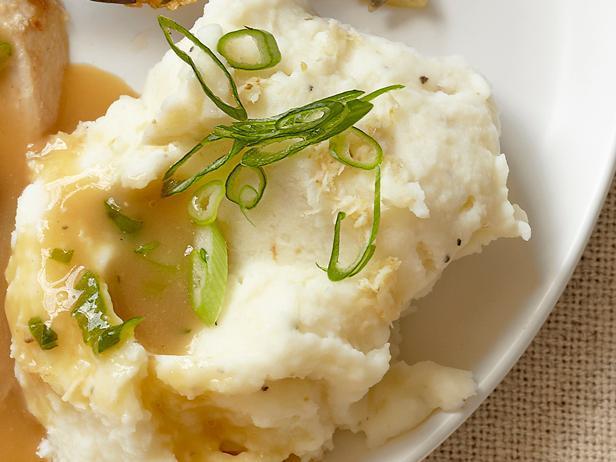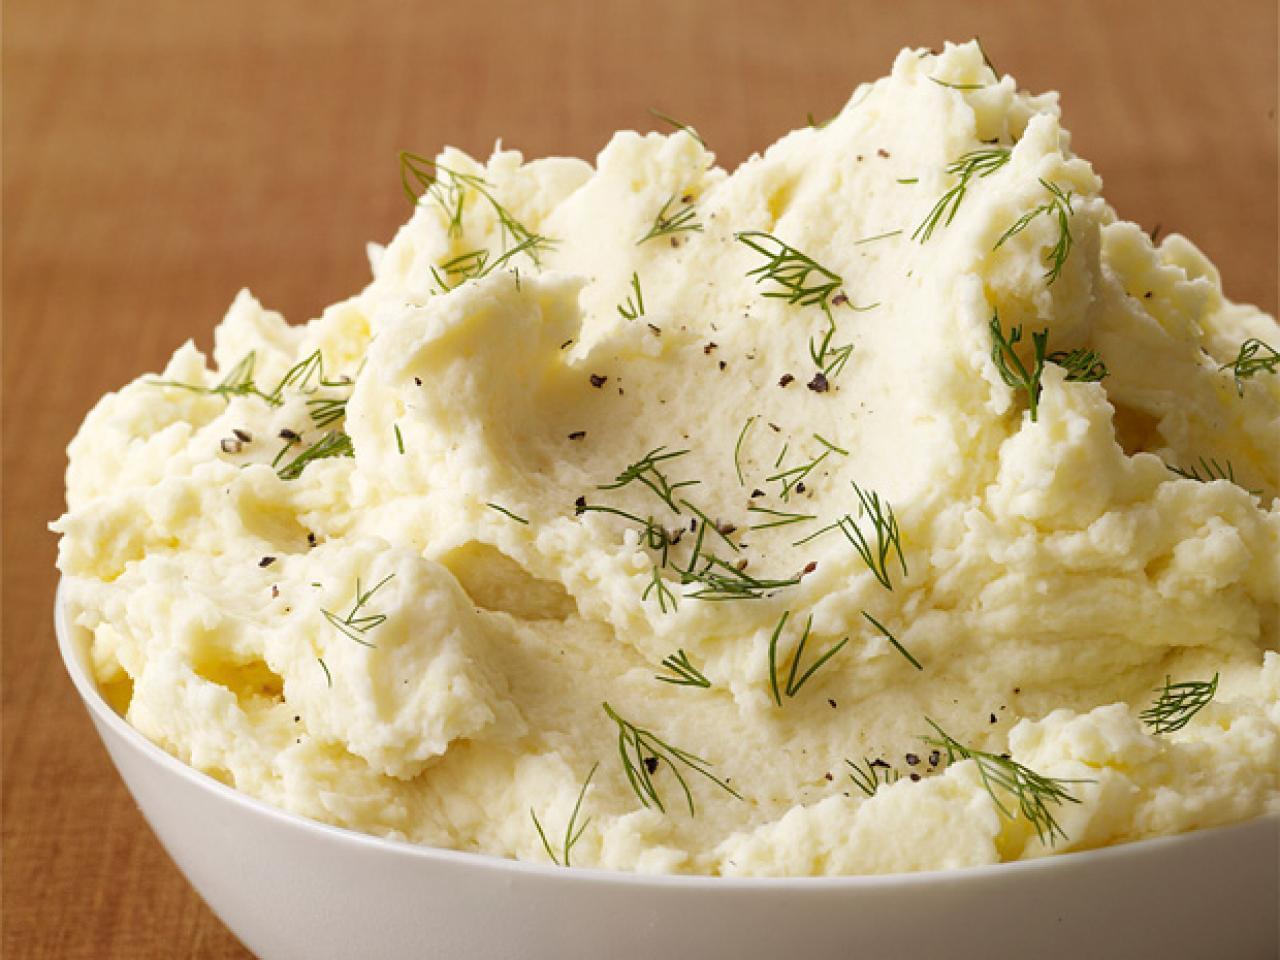The first image is the image on the left, the second image is the image on the right. Analyze the images presented: Is the assertion "A handle is sticking out of the round bowl of potatoes in the right image." valid? Answer yes or no. No. 